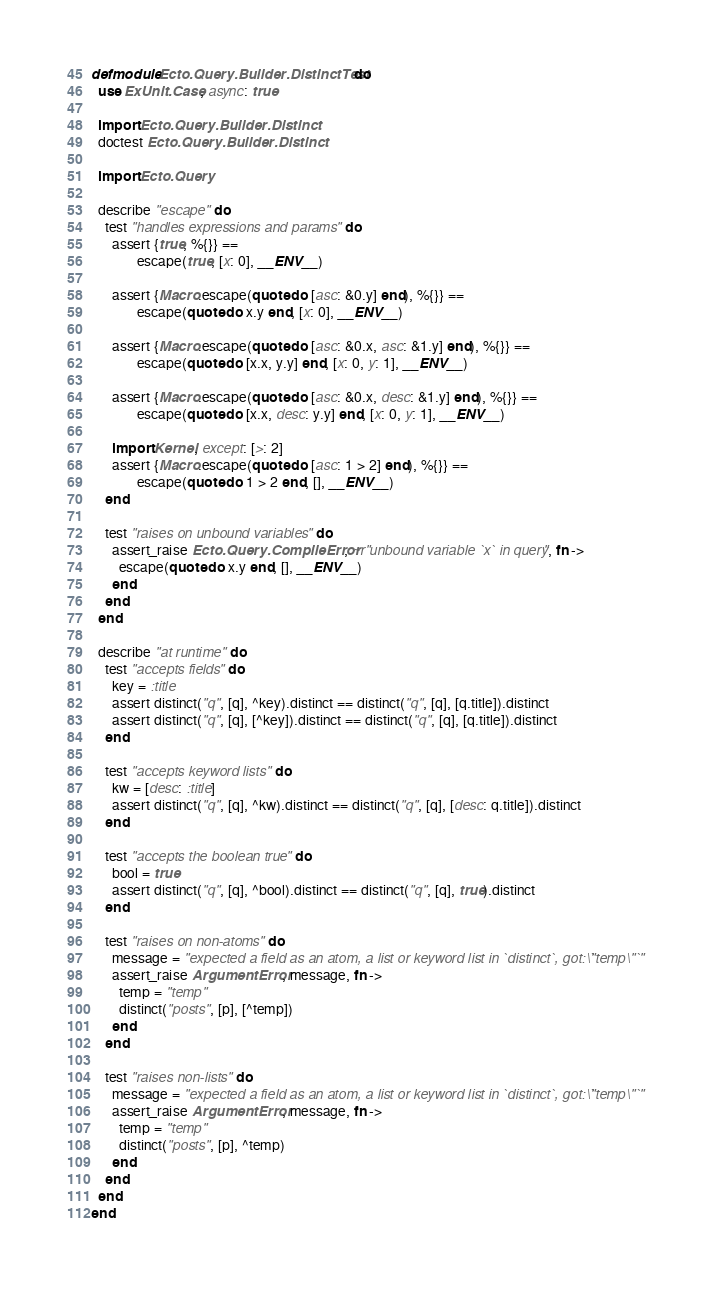<code> <loc_0><loc_0><loc_500><loc_500><_Elixir_>defmodule Ecto.Query.Builder.DistinctTest do
  use ExUnit.Case, async: true

  import Ecto.Query.Builder.Distinct
  doctest Ecto.Query.Builder.Distinct

  import Ecto.Query

  describe "escape" do
    test "handles expressions and params" do
      assert {true, %{}} ==
             escape(true, [x: 0], __ENV__)

      assert {Macro.escape(quote do [asc: &0.y] end), %{}} ==
             escape(quote do x.y end, [x: 0], __ENV__)

      assert {Macro.escape(quote do [asc: &0.x, asc: &1.y] end), %{}} ==
             escape(quote do [x.x, y.y] end, [x: 0, y: 1], __ENV__)

      assert {Macro.escape(quote do [asc: &0.x, desc: &1.y] end), %{}} ==
             escape(quote do [x.x, desc: y.y] end, [x: 0, y: 1], __ENV__)

      import Kernel, except: [>: 2]
      assert {Macro.escape(quote do [asc: 1 > 2] end), %{}} ==
             escape(quote do 1 > 2 end, [], __ENV__)
    end

    test "raises on unbound variables" do
      assert_raise Ecto.Query.CompileError, ~r"unbound variable `x` in query", fn ->
        escape(quote do x.y end, [], __ENV__)
      end
    end
  end

  describe "at runtime" do
    test "accepts fields" do
      key = :title
      assert distinct("q", [q], ^key).distinct == distinct("q", [q], [q.title]).distinct
      assert distinct("q", [q], [^key]).distinct == distinct("q", [q], [q.title]).distinct
    end

    test "accepts keyword lists" do
      kw = [desc: :title]
      assert distinct("q", [q], ^kw).distinct == distinct("q", [q], [desc: q.title]).distinct
    end

    test "accepts the boolean true" do
      bool = true
      assert distinct("q", [q], ^bool).distinct == distinct("q", [q], true).distinct
    end

    test "raises on non-atoms" do
      message = "expected a field as an atom, a list or keyword list in `distinct`, got: `\"temp\"`"
      assert_raise ArgumentError, message, fn ->
        temp = "temp"
        distinct("posts", [p], [^temp])
      end
    end

    test "raises non-lists" do
      message = "expected a field as an atom, a list or keyword list in `distinct`, got: `\"temp\"`"
      assert_raise ArgumentError, message, fn ->
        temp = "temp"
        distinct("posts", [p], ^temp)
      end
    end
  end
end
</code> 